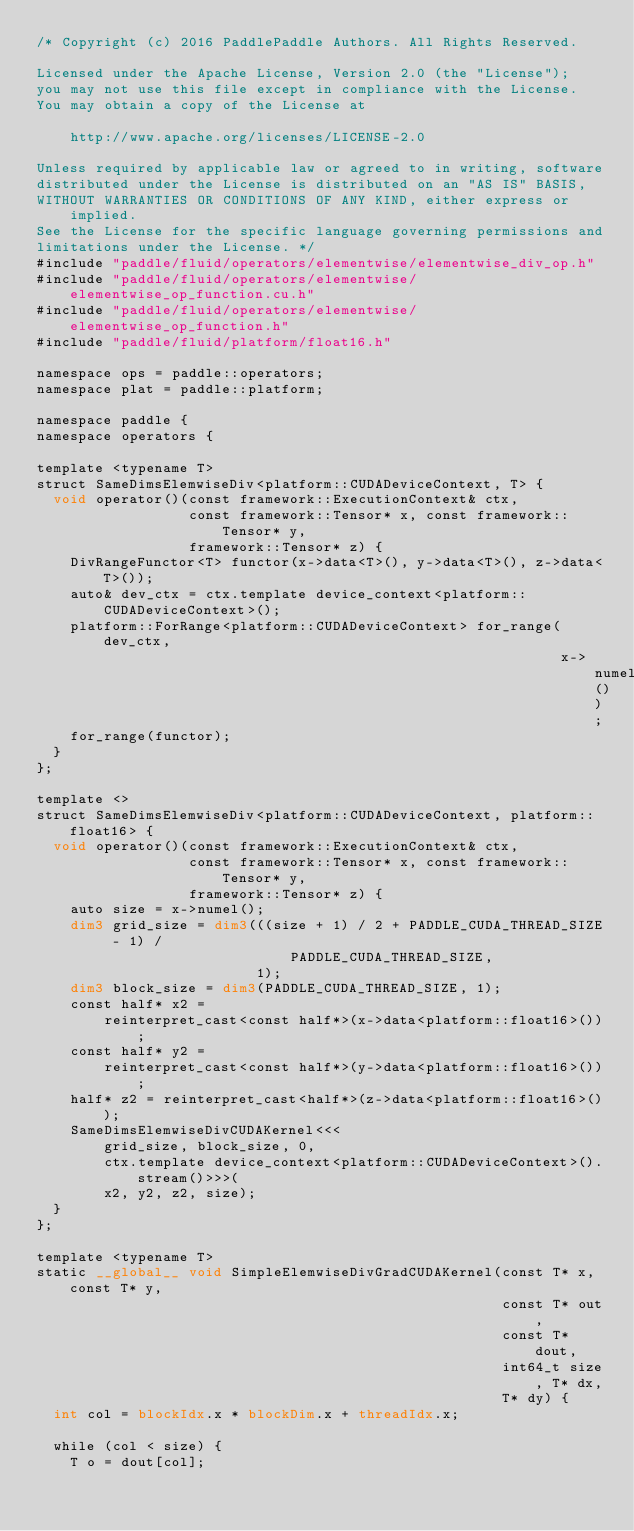Convert code to text. <code><loc_0><loc_0><loc_500><loc_500><_Cuda_>/* Copyright (c) 2016 PaddlePaddle Authors. All Rights Reserved.

Licensed under the Apache License, Version 2.0 (the "License");
you may not use this file except in compliance with the License.
You may obtain a copy of the License at

    http://www.apache.org/licenses/LICENSE-2.0

Unless required by applicable law or agreed to in writing, software
distributed under the License is distributed on an "AS IS" BASIS,
WITHOUT WARRANTIES OR CONDITIONS OF ANY KIND, either express or implied.
See the License for the specific language governing permissions and
limitations under the License. */
#include "paddle/fluid/operators/elementwise/elementwise_div_op.h"
#include "paddle/fluid/operators/elementwise/elementwise_op_function.cu.h"
#include "paddle/fluid/operators/elementwise/elementwise_op_function.h"
#include "paddle/fluid/platform/float16.h"

namespace ops = paddle::operators;
namespace plat = paddle::platform;

namespace paddle {
namespace operators {

template <typename T>
struct SameDimsElemwiseDiv<platform::CUDADeviceContext, T> {
  void operator()(const framework::ExecutionContext& ctx,
                  const framework::Tensor* x, const framework::Tensor* y,
                  framework::Tensor* z) {
    DivRangeFunctor<T> functor(x->data<T>(), y->data<T>(), z->data<T>());
    auto& dev_ctx = ctx.template device_context<platform::CUDADeviceContext>();
    platform::ForRange<platform::CUDADeviceContext> for_range(dev_ctx,
                                                              x->numel());
    for_range(functor);
  }
};

template <>
struct SameDimsElemwiseDiv<platform::CUDADeviceContext, platform::float16> {
  void operator()(const framework::ExecutionContext& ctx,
                  const framework::Tensor* x, const framework::Tensor* y,
                  framework::Tensor* z) {
    auto size = x->numel();
    dim3 grid_size = dim3(((size + 1) / 2 + PADDLE_CUDA_THREAD_SIZE - 1) /
                              PADDLE_CUDA_THREAD_SIZE,
                          1);
    dim3 block_size = dim3(PADDLE_CUDA_THREAD_SIZE, 1);
    const half* x2 =
        reinterpret_cast<const half*>(x->data<platform::float16>());
    const half* y2 =
        reinterpret_cast<const half*>(y->data<platform::float16>());
    half* z2 = reinterpret_cast<half*>(z->data<platform::float16>());
    SameDimsElemwiseDivCUDAKernel<<<
        grid_size, block_size, 0,
        ctx.template device_context<platform::CUDADeviceContext>().stream()>>>(
        x2, y2, z2, size);
  }
};

template <typename T>
static __global__ void SimpleElemwiseDivGradCUDAKernel(const T* x, const T* y,
                                                       const T* out,
                                                       const T* dout,
                                                       int64_t size, T* dx,
                                                       T* dy) {
  int col = blockIdx.x * blockDim.x + threadIdx.x;

  while (col < size) {
    T o = dout[col];</code> 